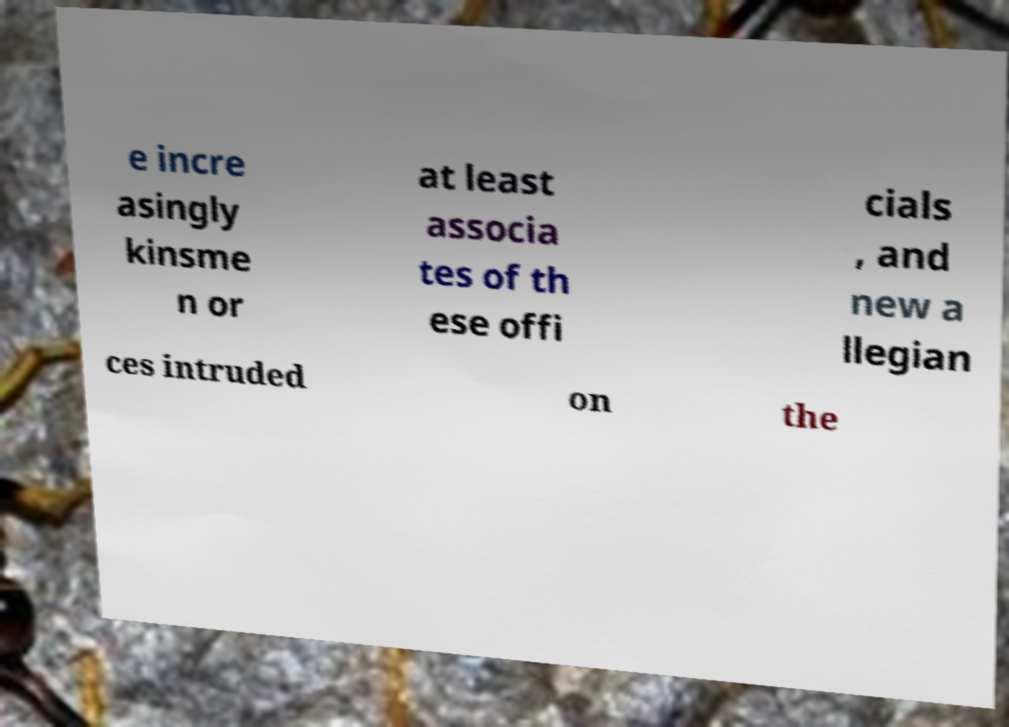What messages or text are displayed in this image? I need them in a readable, typed format. e incre asingly kinsme n or at least associa tes of th ese offi cials , and new a llegian ces intruded on the 